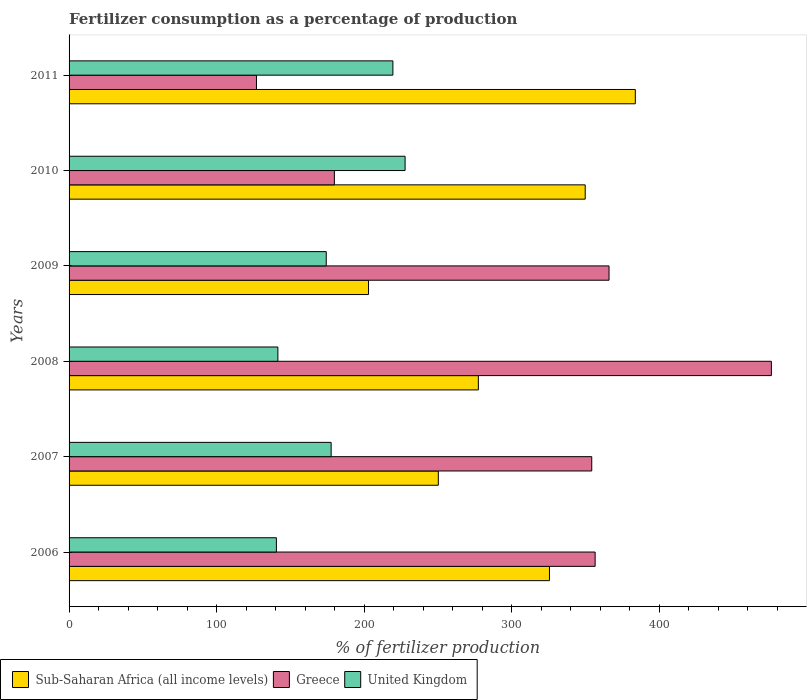How many different coloured bars are there?
Provide a short and direct response. 3. Are the number of bars per tick equal to the number of legend labels?
Give a very brief answer. Yes. How many bars are there on the 1st tick from the bottom?
Provide a succinct answer. 3. In how many cases, is the number of bars for a given year not equal to the number of legend labels?
Give a very brief answer. 0. What is the percentage of fertilizers consumed in Sub-Saharan Africa (all income levels) in 2007?
Your answer should be compact. 250.2. Across all years, what is the maximum percentage of fertilizers consumed in Sub-Saharan Africa (all income levels)?
Provide a succinct answer. 383.69. Across all years, what is the minimum percentage of fertilizers consumed in United Kingdom?
Offer a terse response. 140.49. In which year was the percentage of fertilizers consumed in Sub-Saharan Africa (all income levels) maximum?
Ensure brevity in your answer.  2011. In which year was the percentage of fertilizers consumed in Sub-Saharan Africa (all income levels) minimum?
Offer a very short reply. 2009. What is the total percentage of fertilizers consumed in Greece in the graph?
Offer a very short reply. 1859.19. What is the difference between the percentage of fertilizers consumed in Sub-Saharan Africa (all income levels) in 2010 and that in 2011?
Your response must be concise. -33.95. What is the difference between the percentage of fertilizers consumed in Sub-Saharan Africa (all income levels) in 2006 and the percentage of fertilizers consumed in United Kingdom in 2007?
Your response must be concise. 147.92. What is the average percentage of fertilizers consumed in Sub-Saharan Africa (all income levels) per year?
Make the answer very short. 298.23. In the year 2009, what is the difference between the percentage of fertilizers consumed in United Kingdom and percentage of fertilizers consumed in Sub-Saharan Africa (all income levels)?
Offer a very short reply. -28.65. What is the ratio of the percentage of fertilizers consumed in Sub-Saharan Africa (all income levels) in 2006 to that in 2007?
Offer a terse response. 1.3. Is the percentage of fertilizers consumed in Sub-Saharan Africa (all income levels) in 2007 less than that in 2010?
Make the answer very short. Yes. Is the difference between the percentage of fertilizers consumed in United Kingdom in 2009 and 2011 greater than the difference between the percentage of fertilizers consumed in Sub-Saharan Africa (all income levels) in 2009 and 2011?
Provide a short and direct response. Yes. What is the difference between the highest and the second highest percentage of fertilizers consumed in United Kingdom?
Provide a succinct answer. 8.27. What is the difference between the highest and the lowest percentage of fertilizers consumed in Sub-Saharan Africa (all income levels)?
Your answer should be very brief. 180.77. What does the 2nd bar from the top in 2008 represents?
Offer a terse response. Greece. Is it the case that in every year, the sum of the percentage of fertilizers consumed in United Kingdom and percentage of fertilizers consumed in Sub-Saharan Africa (all income levels) is greater than the percentage of fertilizers consumed in Greece?
Offer a very short reply. No. How many bars are there?
Your response must be concise. 18. Are all the bars in the graph horizontal?
Give a very brief answer. Yes. How many years are there in the graph?
Your answer should be very brief. 6. Does the graph contain any zero values?
Ensure brevity in your answer.  No. Does the graph contain grids?
Keep it short and to the point. No. How many legend labels are there?
Ensure brevity in your answer.  3. What is the title of the graph?
Provide a succinct answer. Fertilizer consumption as a percentage of production. What is the label or title of the X-axis?
Make the answer very short. % of fertilizer production. What is the % of fertilizer production of Sub-Saharan Africa (all income levels) in 2006?
Your response must be concise. 325.51. What is the % of fertilizer production of Greece in 2006?
Your answer should be compact. 356.47. What is the % of fertilizer production in United Kingdom in 2006?
Ensure brevity in your answer.  140.49. What is the % of fertilizer production of Sub-Saharan Africa (all income levels) in 2007?
Offer a terse response. 250.2. What is the % of fertilizer production in Greece in 2007?
Your response must be concise. 354.17. What is the % of fertilizer production in United Kingdom in 2007?
Provide a succinct answer. 177.58. What is the % of fertilizer production in Sub-Saharan Africa (all income levels) in 2008?
Make the answer very short. 277.34. What is the % of fertilizer production of Greece in 2008?
Your answer should be compact. 475.89. What is the % of fertilizer production of United Kingdom in 2008?
Your answer should be compact. 141.49. What is the % of fertilizer production of Sub-Saharan Africa (all income levels) in 2009?
Provide a succinct answer. 202.92. What is the % of fertilizer production in Greece in 2009?
Your response must be concise. 365.89. What is the % of fertilizer production of United Kingdom in 2009?
Offer a very short reply. 174.26. What is the % of fertilizer production in Sub-Saharan Africa (all income levels) in 2010?
Ensure brevity in your answer.  349.74. What is the % of fertilizer production of Greece in 2010?
Provide a succinct answer. 179.77. What is the % of fertilizer production in United Kingdom in 2010?
Offer a terse response. 227.69. What is the % of fertilizer production in Sub-Saharan Africa (all income levels) in 2011?
Your answer should be very brief. 383.69. What is the % of fertilizer production in Greece in 2011?
Keep it short and to the point. 126.98. What is the % of fertilizer production of United Kingdom in 2011?
Offer a very short reply. 219.43. Across all years, what is the maximum % of fertilizer production in Sub-Saharan Africa (all income levels)?
Ensure brevity in your answer.  383.69. Across all years, what is the maximum % of fertilizer production of Greece?
Make the answer very short. 475.89. Across all years, what is the maximum % of fertilizer production of United Kingdom?
Your response must be concise. 227.69. Across all years, what is the minimum % of fertilizer production in Sub-Saharan Africa (all income levels)?
Provide a succinct answer. 202.92. Across all years, what is the minimum % of fertilizer production of Greece?
Make the answer very short. 126.98. Across all years, what is the minimum % of fertilizer production of United Kingdom?
Offer a very short reply. 140.49. What is the total % of fertilizer production of Sub-Saharan Africa (all income levels) in the graph?
Provide a short and direct response. 1789.4. What is the total % of fertilizer production of Greece in the graph?
Your answer should be very brief. 1859.19. What is the total % of fertilizer production in United Kingdom in the graph?
Your answer should be very brief. 1080.94. What is the difference between the % of fertilizer production of Sub-Saharan Africa (all income levels) in 2006 and that in 2007?
Offer a terse response. 75.31. What is the difference between the % of fertilizer production in Greece in 2006 and that in 2007?
Provide a short and direct response. 2.3. What is the difference between the % of fertilizer production of United Kingdom in 2006 and that in 2007?
Make the answer very short. -37.1. What is the difference between the % of fertilizer production of Sub-Saharan Africa (all income levels) in 2006 and that in 2008?
Keep it short and to the point. 48.17. What is the difference between the % of fertilizer production in Greece in 2006 and that in 2008?
Provide a short and direct response. -119.42. What is the difference between the % of fertilizer production in United Kingdom in 2006 and that in 2008?
Provide a short and direct response. -1.01. What is the difference between the % of fertilizer production in Sub-Saharan Africa (all income levels) in 2006 and that in 2009?
Ensure brevity in your answer.  122.59. What is the difference between the % of fertilizer production in Greece in 2006 and that in 2009?
Provide a short and direct response. -9.42. What is the difference between the % of fertilizer production in United Kingdom in 2006 and that in 2009?
Your answer should be compact. -33.78. What is the difference between the % of fertilizer production in Sub-Saharan Africa (all income levels) in 2006 and that in 2010?
Keep it short and to the point. -24.23. What is the difference between the % of fertilizer production of Greece in 2006 and that in 2010?
Keep it short and to the point. 176.7. What is the difference between the % of fertilizer production in United Kingdom in 2006 and that in 2010?
Offer a terse response. -87.2. What is the difference between the % of fertilizer production of Sub-Saharan Africa (all income levels) in 2006 and that in 2011?
Give a very brief answer. -58.18. What is the difference between the % of fertilizer production in Greece in 2006 and that in 2011?
Provide a succinct answer. 229.49. What is the difference between the % of fertilizer production in United Kingdom in 2006 and that in 2011?
Ensure brevity in your answer.  -78.94. What is the difference between the % of fertilizer production of Sub-Saharan Africa (all income levels) in 2007 and that in 2008?
Provide a short and direct response. -27.14. What is the difference between the % of fertilizer production in Greece in 2007 and that in 2008?
Your answer should be very brief. -121.72. What is the difference between the % of fertilizer production of United Kingdom in 2007 and that in 2008?
Provide a succinct answer. 36.09. What is the difference between the % of fertilizer production in Sub-Saharan Africa (all income levels) in 2007 and that in 2009?
Make the answer very short. 47.29. What is the difference between the % of fertilizer production of Greece in 2007 and that in 2009?
Your answer should be very brief. -11.71. What is the difference between the % of fertilizer production of United Kingdom in 2007 and that in 2009?
Provide a short and direct response. 3.32. What is the difference between the % of fertilizer production of Sub-Saharan Africa (all income levels) in 2007 and that in 2010?
Provide a succinct answer. -99.54. What is the difference between the % of fertilizer production in Greece in 2007 and that in 2010?
Your response must be concise. 174.4. What is the difference between the % of fertilizer production of United Kingdom in 2007 and that in 2010?
Offer a very short reply. -50.11. What is the difference between the % of fertilizer production in Sub-Saharan Africa (all income levels) in 2007 and that in 2011?
Keep it short and to the point. -133.49. What is the difference between the % of fertilizer production in Greece in 2007 and that in 2011?
Offer a terse response. 227.19. What is the difference between the % of fertilizer production in United Kingdom in 2007 and that in 2011?
Offer a very short reply. -41.84. What is the difference between the % of fertilizer production of Sub-Saharan Africa (all income levels) in 2008 and that in 2009?
Your response must be concise. 74.42. What is the difference between the % of fertilizer production in Greece in 2008 and that in 2009?
Provide a short and direct response. 110. What is the difference between the % of fertilizer production in United Kingdom in 2008 and that in 2009?
Keep it short and to the point. -32.77. What is the difference between the % of fertilizer production of Sub-Saharan Africa (all income levels) in 2008 and that in 2010?
Give a very brief answer. -72.4. What is the difference between the % of fertilizer production in Greece in 2008 and that in 2010?
Give a very brief answer. 296.12. What is the difference between the % of fertilizer production in United Kingdom in 2008 and that in 2010?
Offer a terse response. -86.2. What is the difference between the % of fertilizer production in Sub-Saharan Africa (all income levels) in 2008 and that in 2011?
Your answer should be compact. -106.35. What is the difference between the % of fertilizer production of Greece in 2008 and that in 2011?
Give a very brief answer. 348.91. What is the difference between the % of fertilizer production of United Kingdom in 2008 and that in 2011?
Keep it short and to the point. -77.93. What is the difference between the % of fertilizer production in Sub-Saharan Africa (all income levels) in 2009 and that in 2010?
Provide a short and direct response. -146.83. What is the difference between the % of fertilizer production in Greece in 2009 and that in 2010?
Provide a short and direct response. 186.12. What is the difference between the % of fertilizer production in United Kingdom in 2009 and that in 2010?
Keep it short and to the point. -53.43. What is the difference between the % of fertilizer production in Sub-Saharan Africa (all income levels) in 2009 and that in 2011?
Give a very brief answer. -180.77. What is the difference between the % of fertilizer production in Greece in 2009 and that in 2011?
Provide a short and direct response. 238.9. What is the difference between the % of fertilizer production in United Kingdom in 2009 and that in 2011?
Ensure brevity in your answer.  -45.16. What is the difference between the % of fertilizer production of Sub-Saharan Africa (all income levels) in 2010 and that in 2011?
Your answer should be compact. -33.95. What is the difference between the % of fertilizer production in Greece in 2010 and that in 2011?
Your response must be concise. 52.79. What is the difference between the % of fertilizer production in United Kingdom in 2010 and that in 2011?
Keep it short and to the point. 8.27. What is the difference between the % of fertilizer production of Sub-Saharan Africa (all income levels) in 2006 and the % of fertilizer production of Greece in 2007?
Provide a short and direct response. -28.67. What is the difference between the % of fertilizer production in Sub-Saharan Africa (all income levels) in 2006 and the % of fertilizer production in United Kingdom in 2007?
Provide a short and direct response. 147.92. What is the difference between the % of fertilizer production of Greece in 2006 and the % of fertilizer production of United Kingdom in 2007?
Offer a terse response. 178.89. What is the difference between the % of fertilizer production in Sub-Saharan Africa (all income levels) in 2006 and the % of fertilizer production in Greece in 2008?
Ensure brevity in your answer.  -150.38. What is the difference between the % of fertilizer production of Sub-Saharan Africa (all income levels) in 2006 and the % of fertilizer production of United Kingdom in 2008?
Ensure brevity in your answer.  184.02. What is the difference between the % of fertilizer production of Greece in 2006 and the % of fertilizer production of United Kingdom in 2008?
Make the answer very short. 214.98. What is the difference between the % of fertilizer production of Sub-Saharan Africa (all income levels) in 2006 and the % of fertilizer production of Greece in 2009?
Provide a succinct answer. -40.38. What is the difference between the % of fertilizer production in Sub-Saharan Africa (all income levels) in 2006 and the % of fertilizer production in United Kingdom in 2009?
Provide a short and direct response. 151.25. What is the difference between the % of fertilizer production of Greece in 2006 and the % of fertilizer production of United Kingdom in 2009?
Ensure brevity in your answer.  182.21. What is the difference between the % of fertilizer production in Sub-Saharan Africa (all income levels) in 2006 and the % of fertilizer production in Greece in 2010?
Provide a succinct answer. 145.74. What is the difference between the % of fertilizer production in Sub-Saharan Africa (all income levels) in 2006 and the % of fertilizer production in United Kingdom in 2010?
Offer a terse response. 97.82. What is the difference between the % of fertilizer production of Greece in 2006 and the % of fertilizer production of United Kingdom in 2010?
Provide a succinct answer. 128.78. What is the difference between the % of fertilizer production of Sub-Saharan Africa (all income levels) in 2006 and the % of fertilizer production of Greece in 2011?
Your response must be concise. 198.52. What is the difference between the % of fertilizer production in Sub-Saharan Africa (all income levels) in 2006 and the % of fertilizer production in United Kingdom in 2011?
Offer a very short reply. 106.08. What is the difference between the % of fertilizer production in Greece in 2006 and the % of fertilizer production in United Kingdom in 2011?
Provide a short and direct response. 137.04. What is the difference between the % of fertilizer production of Sub-Saharan Africa (all income levels) in 2007 and the % of fertilizer production of Greece in 2008?
Offer a terse response. -225.69. What is the difference between the % of fertilizer production in Sub-Saharan Africa (all income levels) in 2007 and the % of fertilizer production in United Kingdom in 2008?
Make the answer very short. 108.71. What is the difference between the % of fertilizer production of Greece in 2007 and the % of fertilizer production of United Kingdom in 2008?
Give a very brief answer. 212.68. What is the difference between the % of fertilizer production in Sub-Saharan Africa (all income levels) in 2007 and the % of fertilizer production in Greece in 2009?
Keep it short and to the point. -115.69. What is the difference between the % of fertilizer production in Sub-Saharan Africa (all income levels) in 2007 and the % of fertilizer production in United Kingdom in 2009?
Keep it short and to the point. 75.94. What is the difference between the % of fertilizer production in Greece in 2007 and the % of fertilizer production in United Kingdom in 2009?
Make the answer very short. 179.91. What is the difference between the % of fertilizer production of Sub-Saharan Africa (all income levels) in 2007 and the % of fertilizer production of Greece in 2010?
Your answer should be compact. 70.43. What is the difference between the % of fertilizer production in Sub-Saharan Africa (all income levels) in 2007 and the % of fertilizer production in United Kingdom in 2010?
Make the answer very short. 22.51. What is the difference between the % of fertilizer production of Greece in 2007 and the % of fertilizer production of United Kingdom in 2010?
Offer a very short reply. 126.48. What is the difference between the % of fertilizer production in Sub-Saharan Africa (all income levels) in 2007 and the % of fertilizer production in Greece in 2011?
Your answer should be compact. 123.22. What is the difference between the % of fertilizer production in Sub-Saharan Africa (all income levels) in 2007 and the % of fertilizer production in United Kingdom in 2011?
Offer a terse response. 30.78. What is the difference between the % of fertilizer production in Greece in 2007 and the % of fertilizer production in United Kingdom in 2011?
Offer a very short reply. 134.75. What is the difference between the % of fertilizer production in Sub-Saharan Africa (all income levels) in 2008 and the % of fertilizer production in Greece in 2009?
Offer a very short reply. -88.55. What is the difference between the % of fertilizer production of Sub-Saharan Africa (all income levels) in 2008 and the % of fertilizer production of United Kingdom in 2009?
Your answer should be compact. 103.08. What is the difference between the % of fertilizer production of Greece in 2008 and the % of fertilizer production of United Kingdom in 2009?
Ensure brevity in your answer.  301.63. What is the difference between the % of fertilizer production in Sub-Saharan Africa (all income levels) in 2008 and the % of fertilizer production in Greece in 2010?
Provide a short and direct response. 97.57. What is the difference between the % of fertilizer production of Sub-Saharan Africa (all income levels) in 2008 and the % of fertilizer production of United Kingdom in 2010?
Your answer should be very brief. 49.65. What is the difference between the % of fertilizer production of Greece in 2008 and the % of fertilizer production of United Kingdom in 2010?
Your answer should be very brief. 248.2. What is the difference between the % of fertilizer production of Sub-Saharan Africa (all income levels) in 2008 and the % of fertilizer production of Greece in 2011?
Keep it short and to the point. 150.35. What is the difference between the % of fertilizer production in Sub-Saharan Africa (all income levels) in 2008 and the % of fertilizer production in United Kingdom in 2011?
Offer a very short reply. 57.91. What is the difference between the % of fertilizer production of Greece in 2008 and the % of fertilizer production of United Kingdom in 2011?
Your response must be concise. 256.47. What is the difference between the % of fertilizer production of Sub-Saharan Africa (all income levels) in 2009 and the % of fertilizer production of Greece in 2010?
Your answer should be compact. 23.14. What is the difference between the % of fertilizer production in Sub-Saharan Africa (all income levels) in 2009 and the % of fertilizer production in United Kingdom in 2010?
Offer a terse response. -24.78. What is the difference between the % of fertilizer production of Greece in 2009 and the % of fertilizer production of United Kingdom in 2010?
Provide a succinct answer. 138.2. What is the difference between the % of fertilizer production in Sub-Saharan Africa (all income levels) in 2009 and the % of fertilizer production in Greece in 2011?
Offer a terse response. 75.93. What is the difference between the % of fertilizer production of Sub-Saharan Africa (all income levels) in 2009 and the % of fertilizer production of United Kingdom in 2011?
Give a very brief answer. -16.51. What is the difference between the % of fertilizer production of Greece in 2009 and the % of fertilizer production of United Kingdom in 2011?
Your answer should be very brief. 146.46. What is the difference between the % of fertilizer production of Sub-Saharan Africa (all income levels) in 2010 and the % of fertilizer production of Greece in 2011?
Make the answer very short. 222.76. What is the difference between the % of fertilizer production of Sub-Saharan Africa (all income levels) in 2010 and the % of fertilizer production of United Kingdom in 2011?
Provide a short and direct response. 130.32. What is the difference between the % of fertilizer production in Greece in 2010 and the % of fertilizer production in United Kingdom in 2011?
Offer a very short reply. -39.65. What is the average % of fertilizer production of Sub-Saharan Africa (all income levels) per year?
Ensure brevity in your answer.  298.23. What is the average % of fertilizer production of Greece per year?
Provide a short and direct response. 309.86. What is the average % of fertilizer production of United Kingdom per year?
Your answer should be compact. 180.16. In the year 2006, what is the difference between the % of fertilizer production of Sub-Saharan Africa (all income levels) and % of fertilizer production of Greece?
Make the answer very short. -30.96. In the year 2006, what is the difference between the % of fertilizer production of Sub-Saharan Africa (all income levels) and % of fertilizer production of United Kingdom?
Offer a very short reply. 185.02. In the year 2006, what is the difference between the % of fertilizer production in Greece and % of fertilizer production in United Kingdom?
Your response must be concise. 215.98. In the year 2007, what is the difference between the % of fertilizer production of Sub-Saharan Africa (all income levels) and % of fertilizer production of Greece?
Give a very brief answer. -103.97. In the year 2007, what is the difference between the % of fertilizer production in Sub-Saharan Africa (all income levels) and % of fertilizer production in United Kingdom?
Offer a very short reply. 72.62. In the year 2007, what is the difference between the % of fertilizer production in Greece and % of fertilizer production in United Kingdom?
Ensure brevity in your answer.  176.59. In the year 2008, what is the difference between the % of fertilizer production of Sub-Saharan Africa (all income levels) and % of fertilizer production of Greece?
Offer a very short reply. -198.55. In the year 2008, what is the difference between the % of fertilizer production of Sub-Saharan Africa (all income levels) and % of fertilizer production of United Kingdom?
Offer a very short reply. 135.85. In the year 2008, what is the difference between the % of fertilizer production in Greece and % of fertilizer production in United Kingdom?
Give a very brief answer. 334.4. In the year 2009, what is the difference between the % of fertilizer production in Sub-Saharan Africa (all income levels) and % of fertilizer production in Greece?
Keep it short and to the point. -162.97. In the year 2009, what is the difference between the % of fertilizer production in Sub-Saharan Africa (all income levels) and % of fertilizer production in United Kingdom?
Your answer should be compact. 28.65. In the year 2009, what is the difference between the % of fertilizer production in Greece and % of fertilizer production in United Kingdom?
Your response must be concise. 191.63. In the year 2010, what is the difference between the % of fertilizer production of Sub-Saharan Africa (all income levels) and % of fertilizer production of Greece?
Your response must be concise. 169.97. In the year 2010, what is the difference between the % of fertilizer production in Sub-Saharan Africa (all income levels) and % of fertilizer production in United Kingdom?
Your response must be concise. 122.05. In the year 2010, what is the difference between the % of fertilizer production in Greece and % of fertilizer production in United Kingdom?
Give a very brief answer. -47.92. In the year 2011, what is the difference between the % of fertilizer production of Sub-Saharan Africa (all income levels) and % of fertilizer production of Greece?
Your answer should be compact. 256.7. In the year 2011, what is the difference between the % of fertilizer production of Sub-Saharan Africa (all income levels) and % of fertilizer production of United Kingdom?
Your response must be concise. 164.26. In the year 2011, what is the difference between the % of fertilizer production in Greece and % of fertilizer production in United Kingdom?
Offer a very short reply. -92.44. What is the ratio of the % of fertilizer production of Sub-Saharan Africa (all income levels) in 2006 to that in 2007?
Offer a terse response. 1.3. What is the ratio of the % of fertilizer production in Greece in 2006 to that in 2007?
Your response must be concise. 1.01. What is the ratio of the % of fertilizer production in United Kingdom in 2006 to that in 2007?
Keep it short and to the point. 0.79. What is the ratio of the % of fertilizer production in Sub-Saharan Africa (all income levels) in 2006 to that in 2008?
Your answer should be compact. 1.17. What is the ratio of the % of fertilizer production of Greece in 2006 to that in 2008?
Keep it short and to the point. 0.75. What is the ratio of the % of fertilizer production in United Kingdom in 2006 to that in 2008?
Your answer should be very brief. 0.99. What is the ratio of the % of fertilizer production of Sub-Saharan Africa (all income levels) in 2006 to that in 2009?
Provide a succinct answer. 1.6. What is the ratio of the % of fertilizer production in Greece in 2006 to that in 2009?
Keep it short and to the point. 0.97. What is the ratio of the % of fertilizer production of United Kingdom in 2006 to that in 2009?
Keep it short and to the point. 0.81. What is the ratio of the % of fertilizer production in Sub-Saharan Africa (all income levels) in 2006 to that in 2010?
Offer a terse response. 0.93. What is the ratio of the % of fertilizer production of Greece in 2006 to that in 2010?
Keep it short and to the point. 1.98. What is the ratio of the % of fertilizer production in United Kingdom in 2006 to that in 2010?
Keep it short and to the point. 0.62. What is the ratio of the % of fertilizer production in Sub-Saharan Africa (all income levels) in 2006 to that in 2011?
Give a very brief answer. 0.85. What is the ratio of the % of fertilizer production in Greece in 2006 to that in 2011?
Keep it short and to the point. 2.81. What is the ratio of the % of fertilizer production in United Kingdom in 2006 to that in 2011?
Your answer should be compact. 0.64. What is the ratio of the % of fertilizer production in Sub-Saharan Africa (all income levels) in 2007 to that in 2008?
Provide a short and direct response. 0.9. What is the ratio of the % of fertilizer production in Greece in 2007 to that in 2008?
Make the answer very short. 0.74. What is the ratio of the % of fertilizer production of United Kingdom in 2007 to that in 2008?
Give a very brief answer. 1.26. What is the ratio of the % of fertilizer production in Sub-Saharan Africa (all income levels) in 2007 to that in 2009?
Your answer should be very brief. 1.23. What is the ratio of the % of fertilizer production in Greece in 2007 to that in 2009?
Offer a terse response. 0.97. What is the ratio of the % of fertilizer production in United Kingdom in 2007 to that in 2009?
Your response must be concise. 1.02. What is the ratio of the % of fertilizer production of Sub-Saharan Africa (all income levels) in 2007 to that in 2010?
Give a very brief answer. 0.72. What is the ratio of the % of fertilizer production of Greece in 2007 to that in 2010?
Offer a very short reply. 1.97. What is the ratio of the % of fertilizer production in United Kingdom in 2007 to that in 2010?
Your answer should be compact. 0.78. What is the ratio of the % of fertilizer production in Sub-Saharan Africa (all income levels) in 2007 to that in 2011?
Your answer should be very brief. 0.65. What is the ratio of the % of fertilizer production of Greece in 2007 to that in 2011?
Give a very brief answer. 2.79. What is the ratio of the % of fertilizer production of United Kingdom in 2007 to that in 2011?
Make the answer very short. 0.81. What is the ratio of the % of fertilizer production in Sub-Saharan Africa (all income levels) in 2008 to that in 2009?
Keep it short and to the point. 1.37. What is the ratio of the % of fertilizer production of Greece in 2008 to that in 2009?
Provide a succinct answer. 1.3. What is the ratio of the % of fertilizer production of United Kingdom in 2008 to that in 2009?
Ensure brevity in your answer.  0.81. What is the ratio of the % of fertilizer production of Sub-Saharan Africa (all income levels) in 2008 to that in 2010?
Your response must be concise. 0.79. What is the ratio of the % of fertilizer production in Greece in 2008 to that in 2010?
Ensure brevity in your answer.  2.65. What is the ratio of the % of fertilizer production of United Kingdom in 2008 to that in 2010?
Make the answer very short. 0.62. What is the ratio of the % of fertilizer production of Sub-Saharan Africa (all income levels) in 2008 to that in 2011?
Provide a short and direct response. 0.72. What is the ratio of the % of fertilizer production of Greece in 2008 to that in 2011?
Ensure brevity in your answer.  3.75. What is the ratio of the % of fertilizer production of United Kingdom in 2008 to that in 2011?
Provide a succinct answer. 0.64. What is the ratio of the % of fertilizer production in Sub-Saharan Africa (all income levels) in 2009 to that in 2010?
Provide a short and direct response. 0.58. What is the ratio of the % of fertilizer production of Greece in 2009 to that in 2010?
Offer a terse response. 2.04. What is the ratio of the % of fertilizer production of United Kingdom in 2009 to that in 2010?
Give a very brief answer. 0.77. What is the ratio of the % of fertilizer production in Sub-Saharan Africa (all income levels) in 2009 to that in 2011?
Offer a terse response. 0.53. What is the ratio of the % of fertilizer production of Greece in 2009 to that in 2011?
Keep it short and to the point. 2.88. What is the ratio of the % of fertilizer production in United Kingdom in 2009 to that in 2011?
Your answer should be very brief. 0.79. What is the ratio of the % of fertilizer production of Sub-Saharan Africa (all income levels) in 2010 to that in 2011?
Your response must be concise. 0.91. What is the ratio of the % of fertilizer production in Greece in 2010 to that in 2011?
Your response must be concise. 1.42. What is the ratio of the % of fertilizer production in United Kingdom in 2010 to that in 2011?
Provide a short and direct response. 1.04. What is the difference between the highest and the second highest % of fertilizer production of Sub-Saharan Africa (all income levels)?
Your answer should be compact. 33.95. What is the difference between the highest and the second highest % of fertilizer production of Greece?
Ensure brevity in your answer.  110. What is the difference between the highest and the second highest % of fertilizer production of United Kingdom?
Keep it short and to the point. 8.27. What is the difference between the highest and the lowest % of fertilizer production in Sub-Saharan Africa (all income levels)?
Your response must be concise. 180.77. What is the difference between the highest and the lowest % of fertilizer production of Greece?
Provide a succinct answer. 348.91. What is the difference between the highest and the lowest % of fertilizer production in United Kingdom?
Provide a succinct answer. 87.2. 